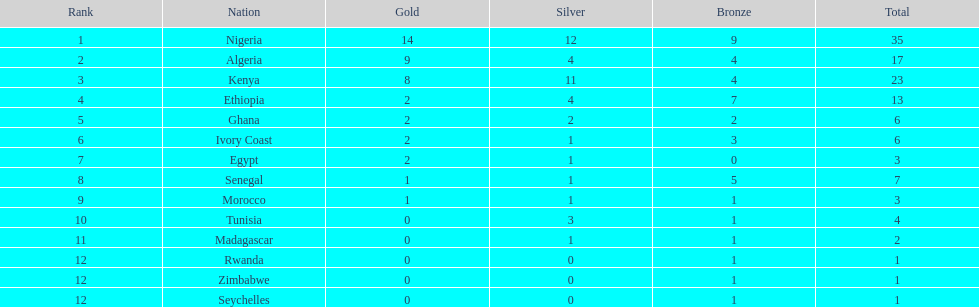The country that won the most medals was? Nigeria. 